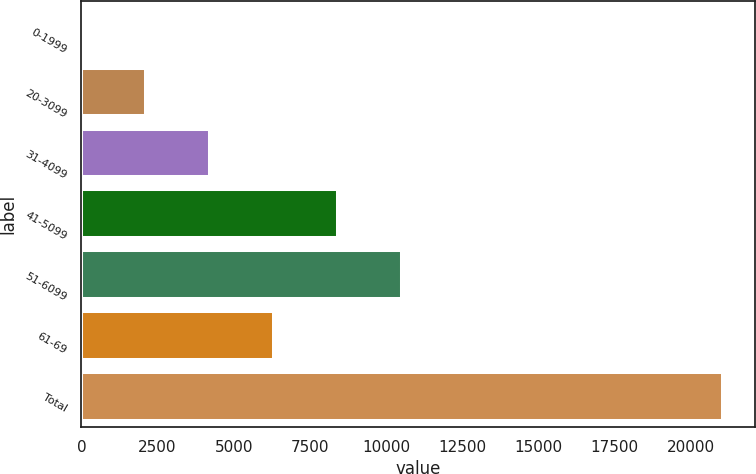<chart> <loc_0><loc_0><loc_500><loc_500><bar_chart><fcel>0-1999<fcel>20-3099<fcel>31-4099<fcel>41-5099<fcel>51-6099<fcel>61-69<fcel>Total<nl><fcel>2<fcel>2107.5<fcel>4213<fcel>8424<fcel>10529.5<fcel>6318.5<fcel>21057<nl></chart> 